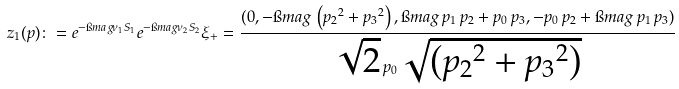<formula> <loc_0><loc_0><loc_500><loc_500>z _ { 1 } ( p ) \colon = e ^ { - \i m a g \nu _ { 1 } S _ { 1 } } e ^ { - \i m a g \nu _ { 2 } S _ { 2 } } \xi _ { + } = \frac { ( 0 , - \i m a g \, \left ( { p _ { 2 } } ^ { 2 } + { p _ { 3 } } ^ { 2 } \right ) , \i m a g \, p _ { 1 } \, p _ { 2 } + { p _ { 0 } } \, { p _ { 3 } } , - { p _ { 0 } } \, { p _ { 2 } } + \i m a g \, { p _ { 1 } } \, { p _ { 3 } } ) } { { \sqrt { 2 } } \, p _ { 0 } \, \sqrt { \left ( { p _ { 2 } } ^ { 2 } + { p _ { 3 } } ^ { 2 } \right ) } }</formula> 